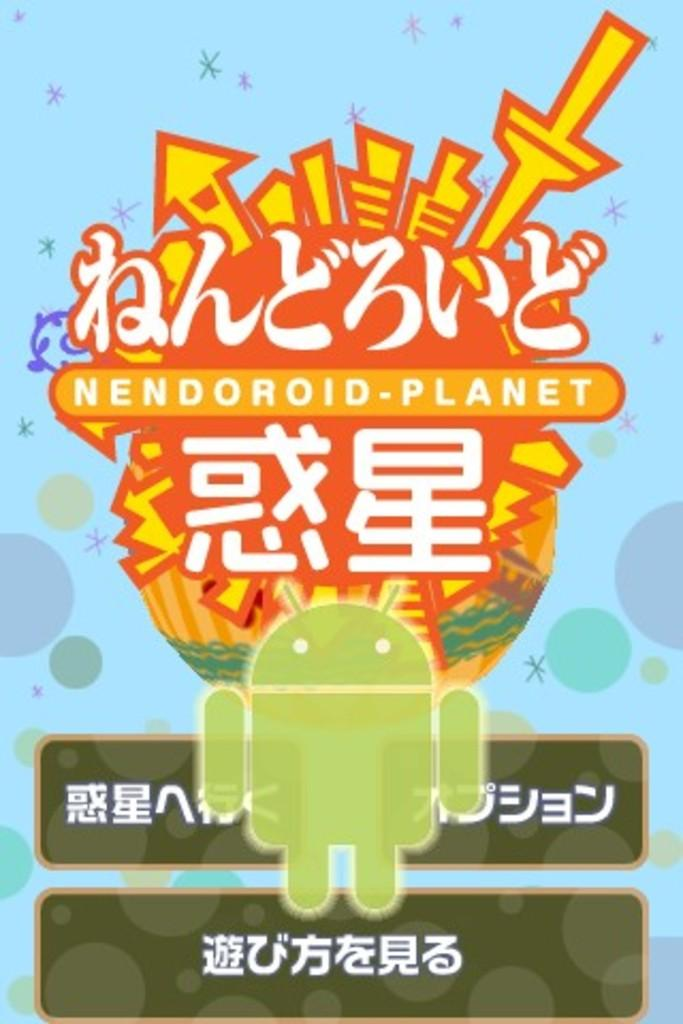What is the main subject of the image? There is an advertisement in the image. What type of jam is being advertised in the image? There is no jam being advertised in the image; it only features an advertisement. What size is the wrench shown in the image? There is no wrench present in the image. 